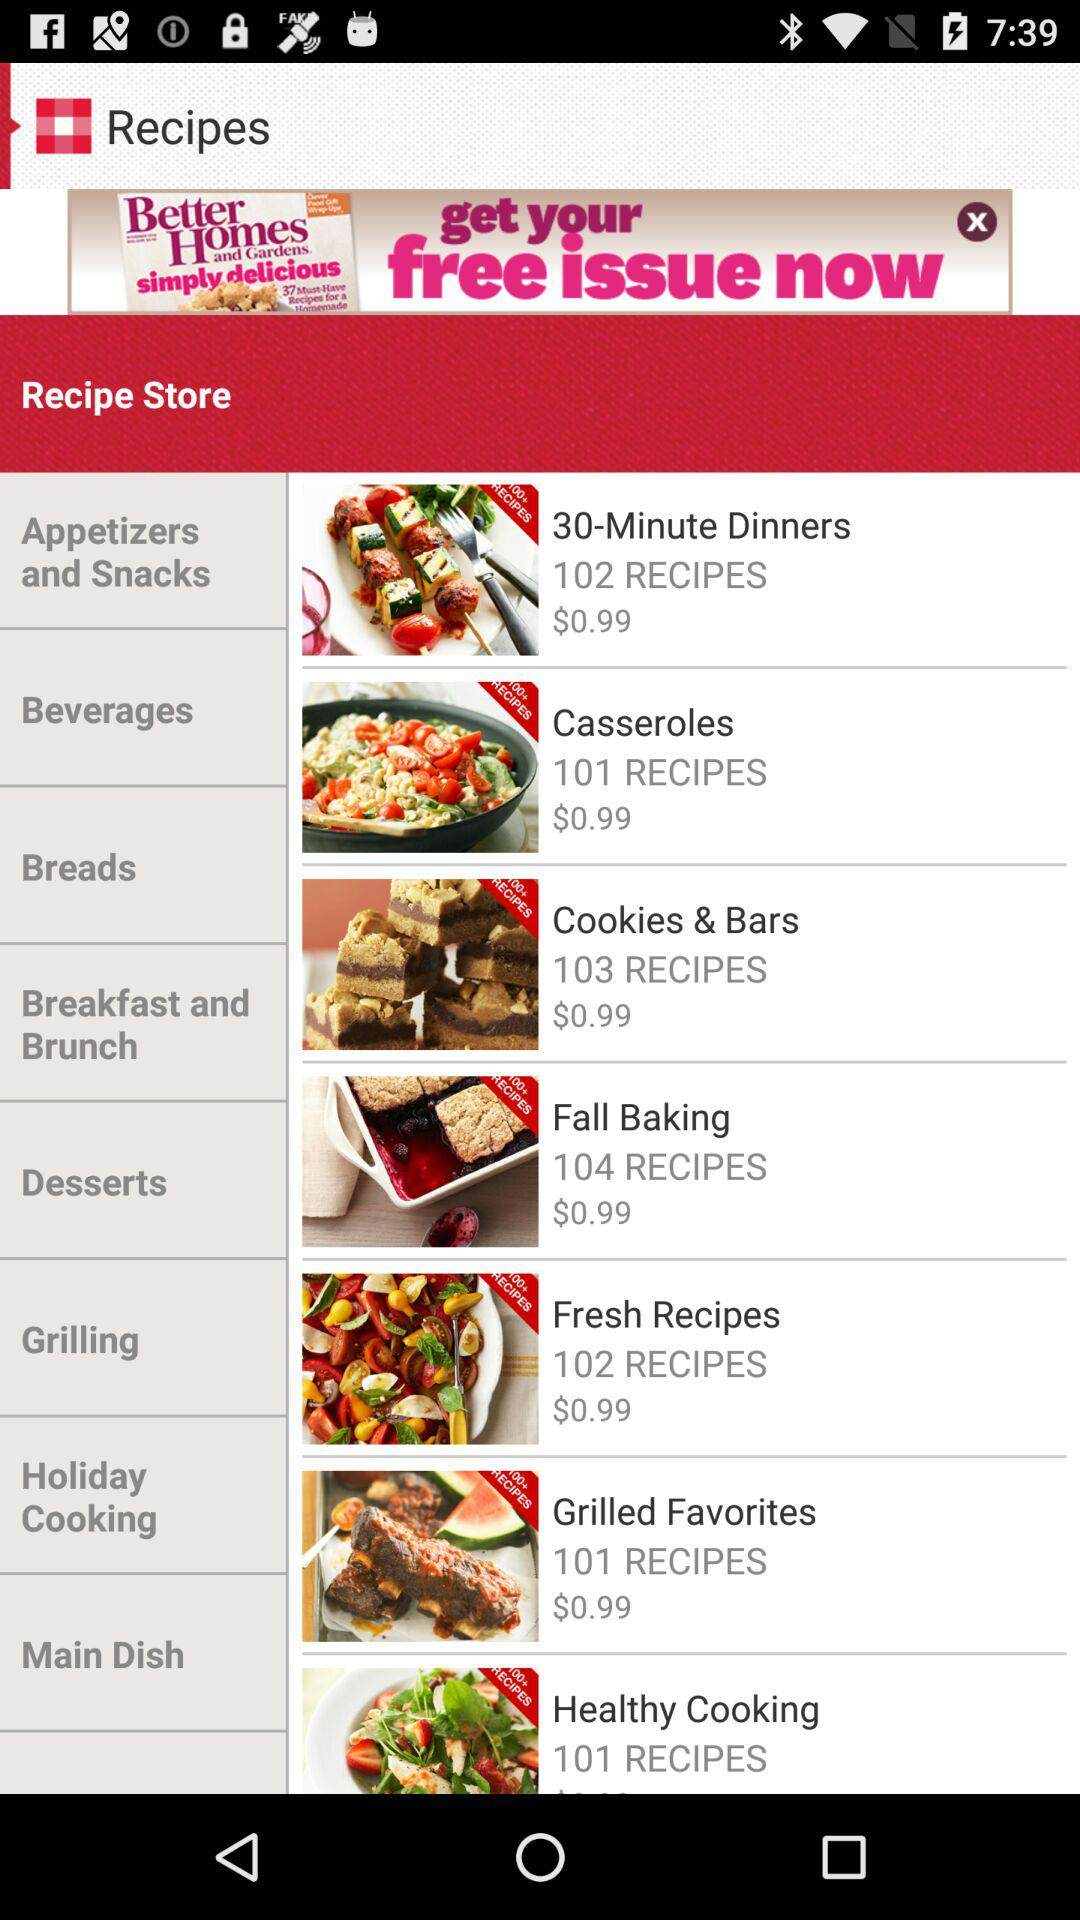What is the price of "Grilled Favorites"? The price of "Grilled Favorites" is $0.99. 